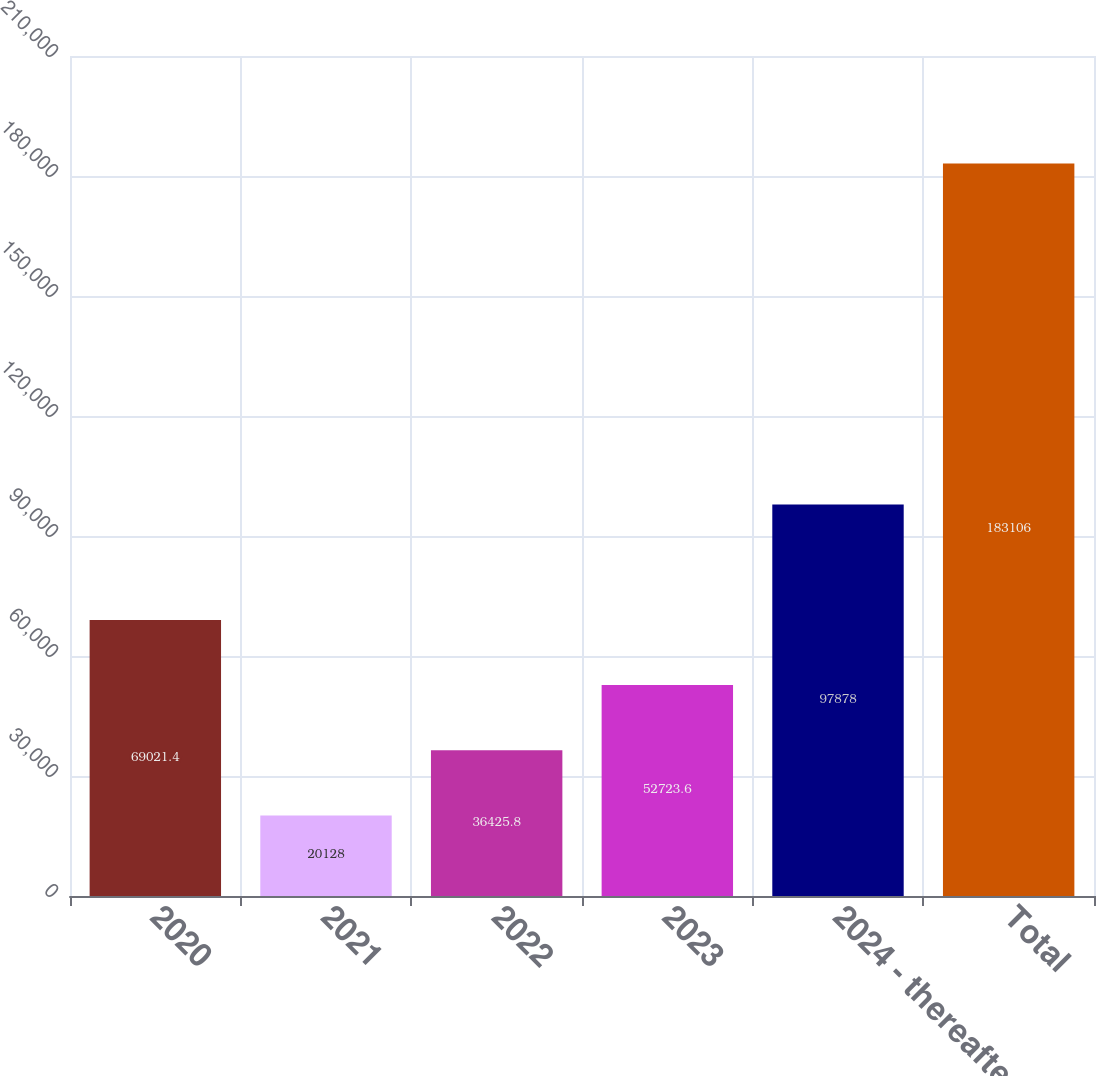Convert chart. <chart><loc_0><loc_0><loc_500><loc_500><bar_chart><fcel>2020<fcel>2021<fcel>2022<fcel>2023<fcel>2024 - thereafter<fcel>Total<nl><fcel>69021.4<fcel>20128<fcel>36425.8<fcel>52723.6<fcel>97878<fcel>183106<nl></chart> 